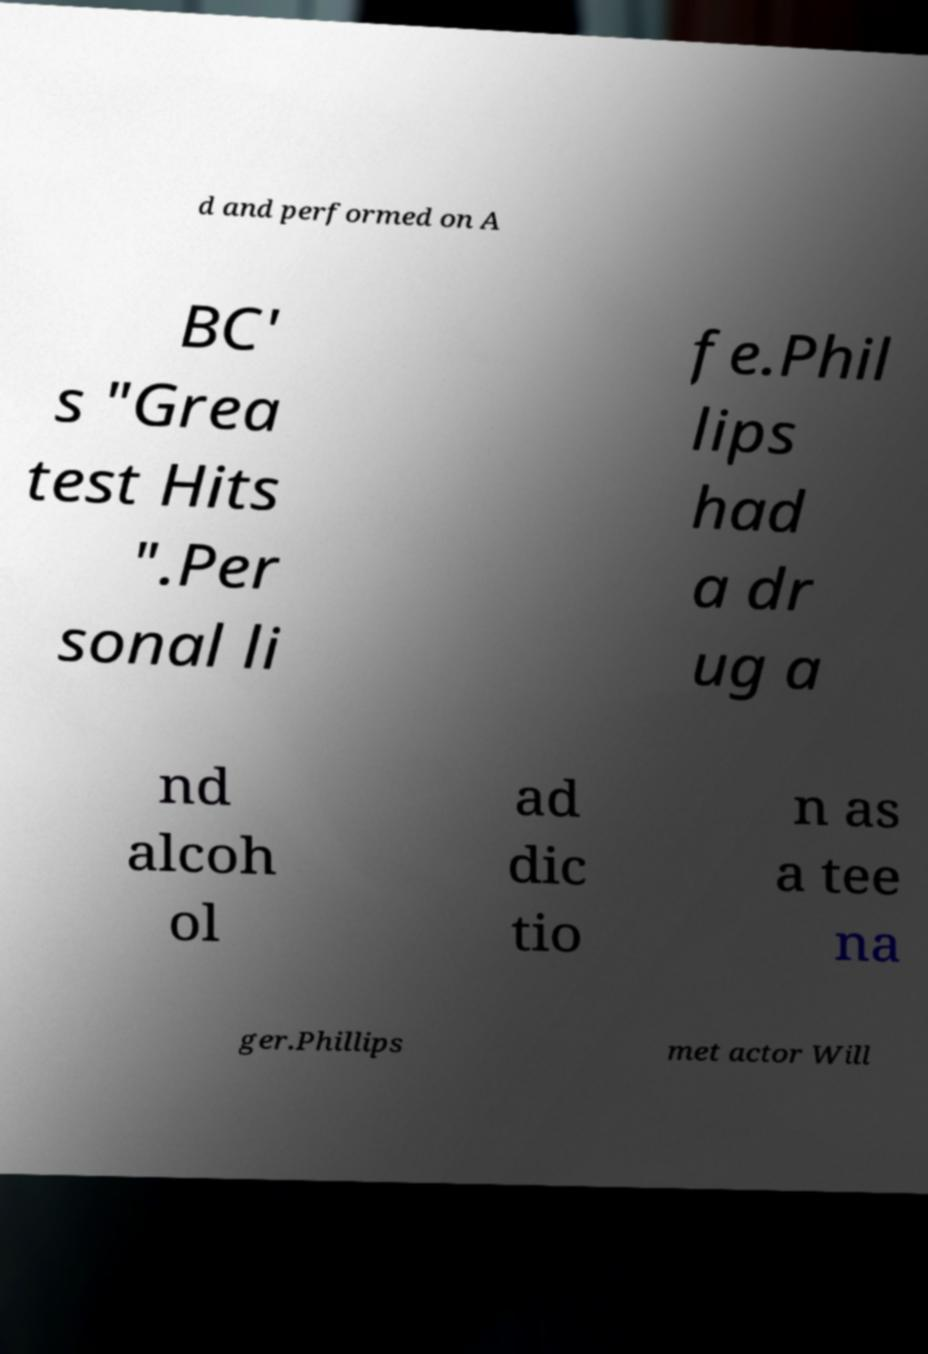Please identify and transcribe the text found in this image. d and performed on A BC' s "Grea test Hits ".Per sonal li fe.Phil lips had a dr ug a nd alcoh ol ad dic tio n as a tee na ger.Phillips met actor Will 